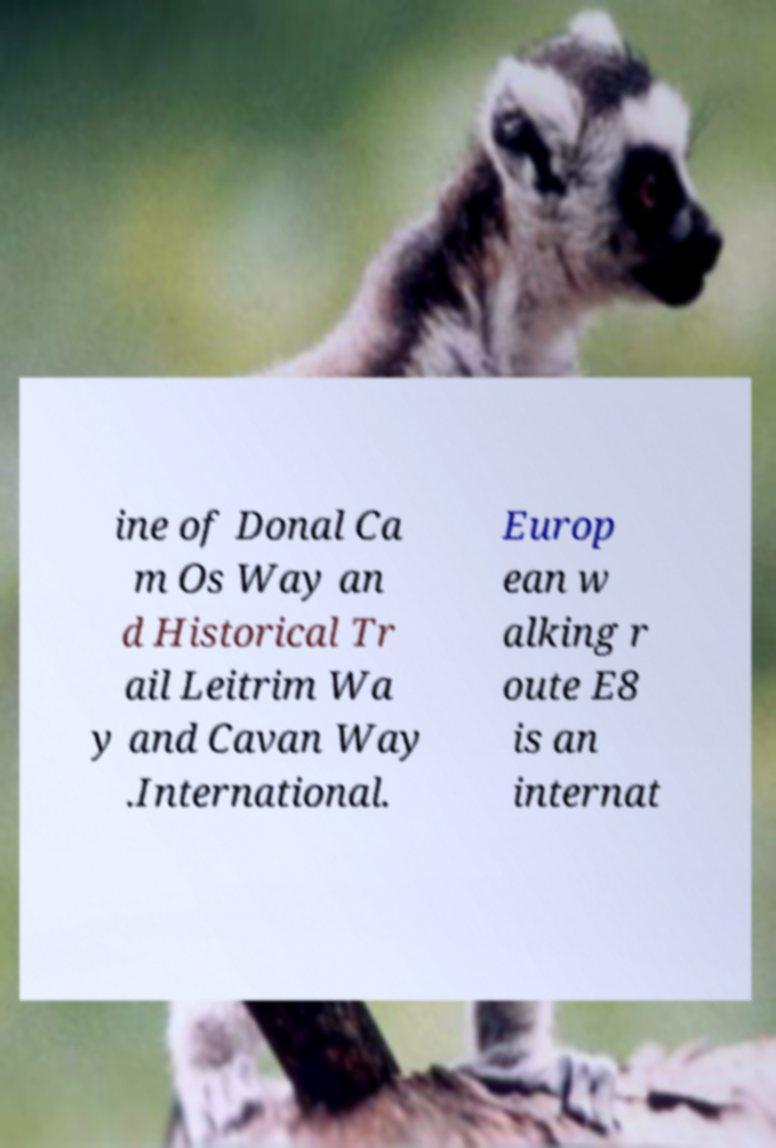For documentation purposes, I need the text within this image transcribed. Could you provide that? ine of Donal Ca m Os Way an d Historical Tr ail Leitrim Wa y and Cavan Way .International. Europ ean w alking r oute E8 is an internat 